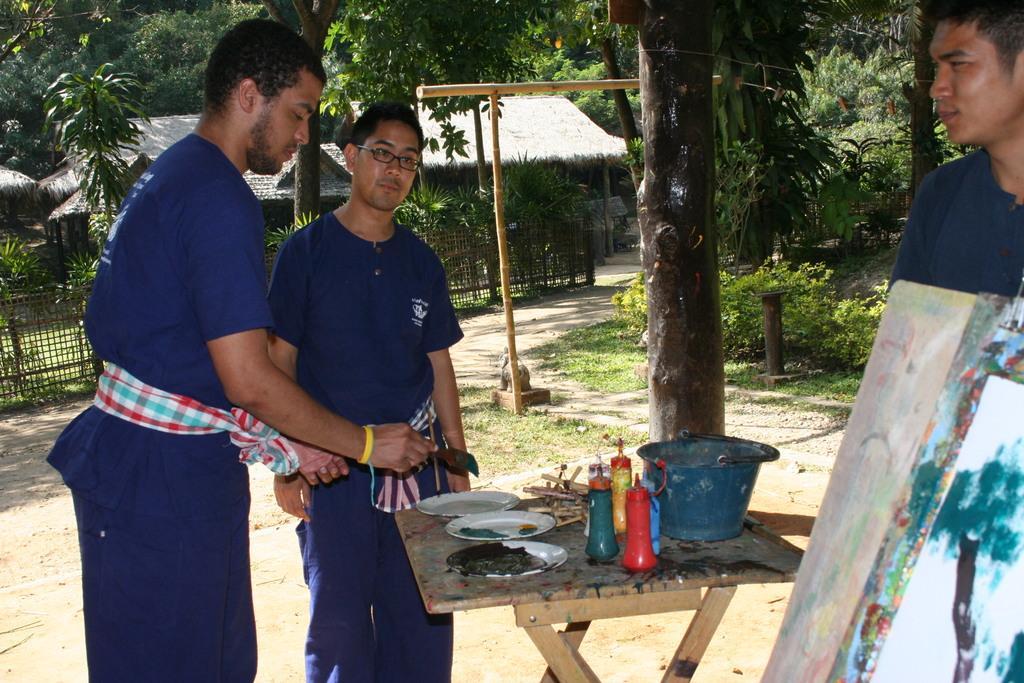Could you give a brief overview of what you see in this image? In this image, there are two persons standing. At the bottom of the image, I can see plates, bottles, a bucket and few other things on a wooden table. On the right side of the image, I can see a board and there is another person. In the background, there are trees, huts, plants and fence. 